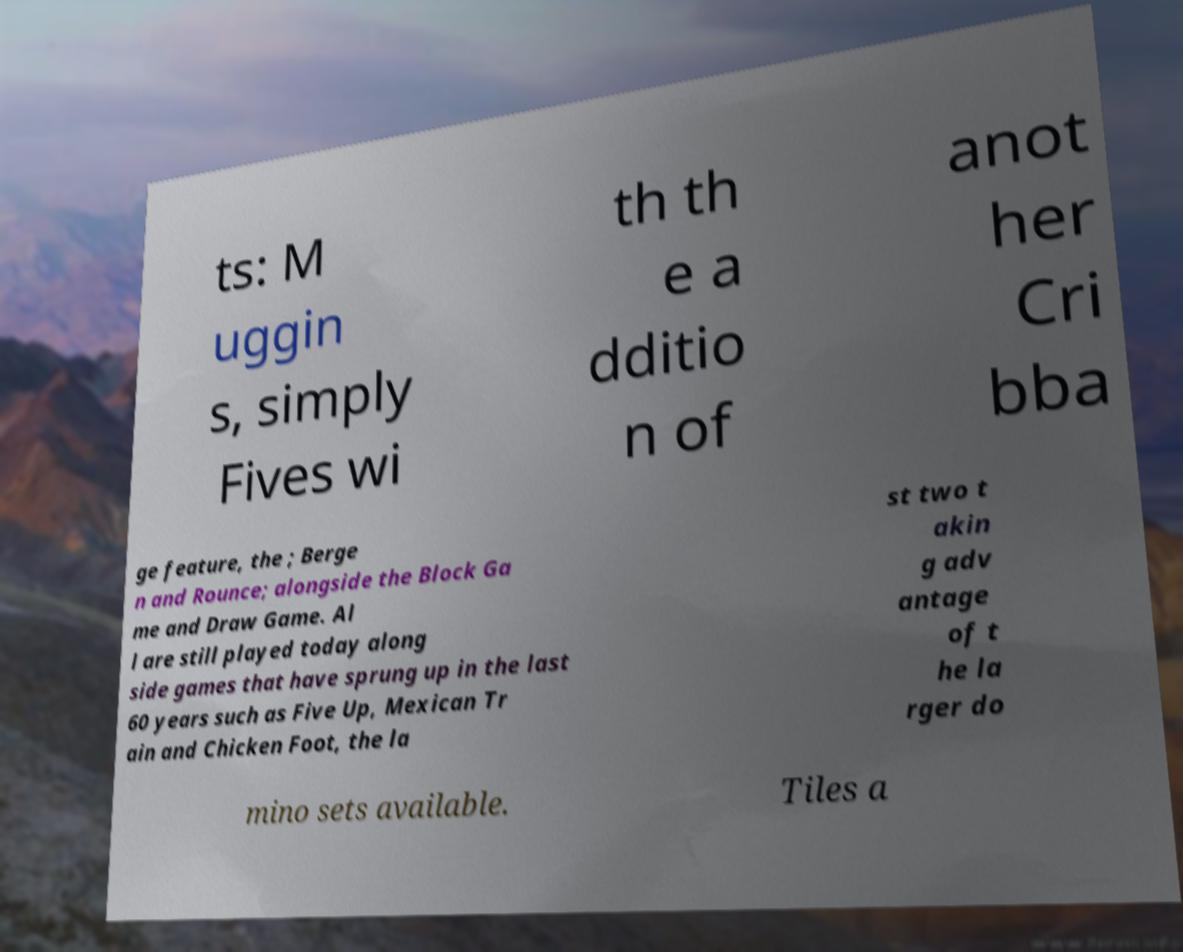Could you extract and type out the text from this image? ts: M uggin s, simply Fives wi th th e a dditio n of anot her Cri bba ge feature, the ; Berge n and Rounce; alongside the Block Ga me and Draw Game. Al l are still played today along side games that have sprung up in the last 60 years such as Five Up, Mexican Tr ain and Chicken Foot, the la st two t akin g adv antage of t he la rger do mino sets available. Tiles a 